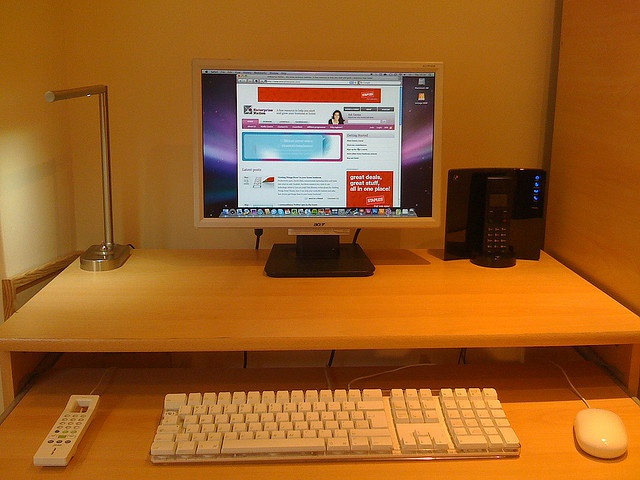Describe the objects in this image and their specific colors. I can see tv in brown, lightgray, black, and darkgray tones, keyboard in brown, orange, olive, and tan tones, remote in brown, olive, and tan tones, mouse in brown and orange tones, and remote in brown, black, and maroon tones in this image. 